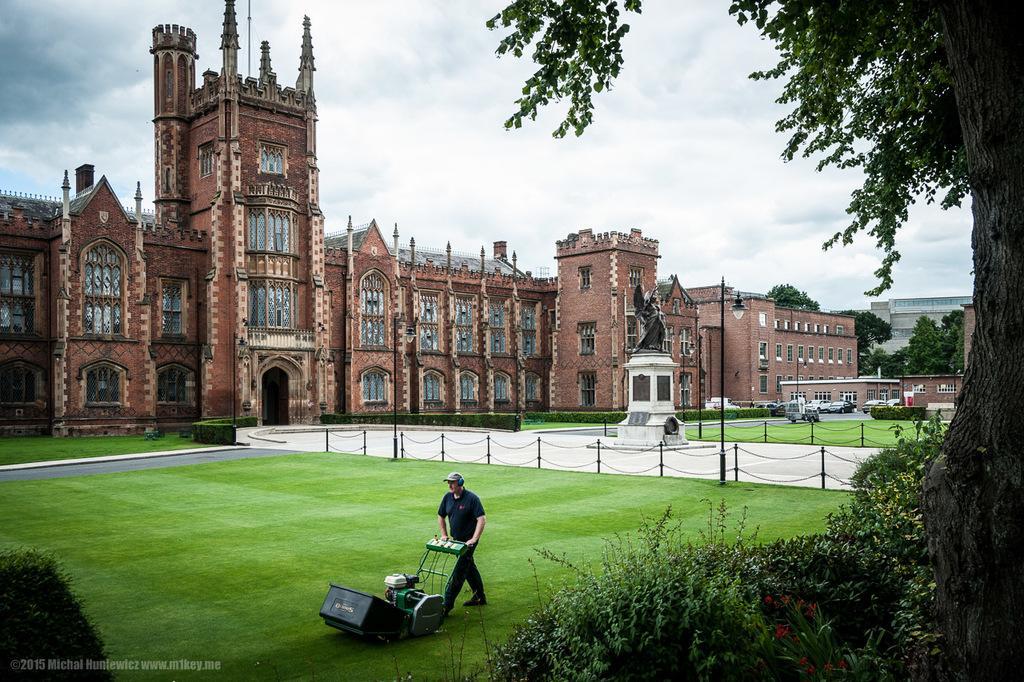Can you describe this image briefly? In this image we can see a man, grass cutter, plants, flowers, grass, poles, statue, vehicles, buildings, road, and trees. In the background there is sky with clouds. 